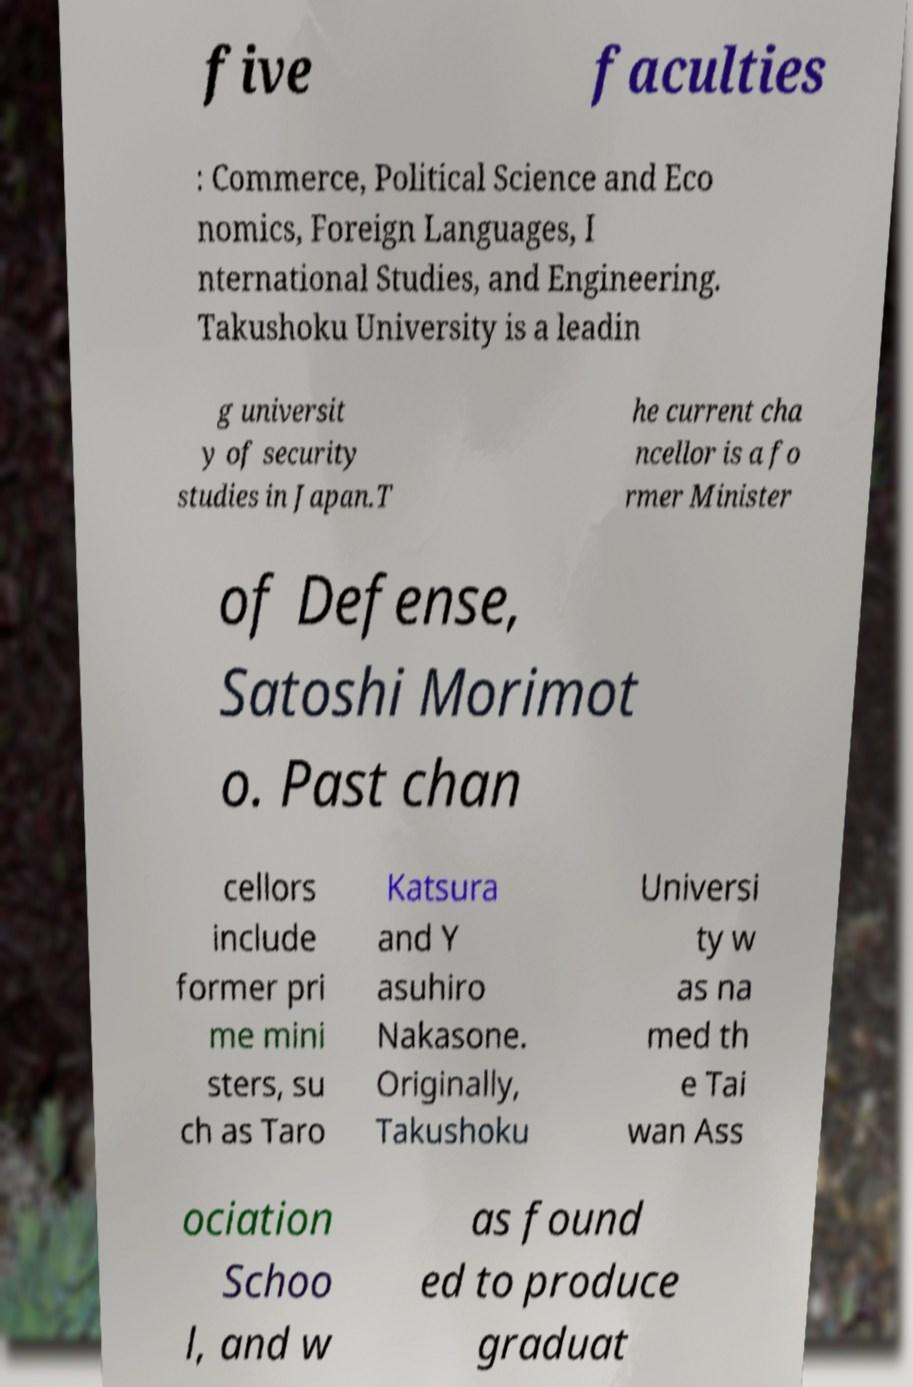For documentation purposes, I need the text within this image transcribed. Could you provide that? five faculties : Commerce, Political Science and Eco nomics, Foreign Languages, I nternational Studies, and Engineering. Takushoku University is a leadin g universit y of security studies in Japan.T he current cha ncellor is a fo rmer Minister of Defense, Satoshi Morimot o. Past chan cellors include former pri me mini sters, su ch as Taro Katsura and Y asuhiro Nakasone. Originally, Takushoku Universi ty w as na med th e Tai wan Ass ociation Schoo l, and w as found ed to produce graduat 